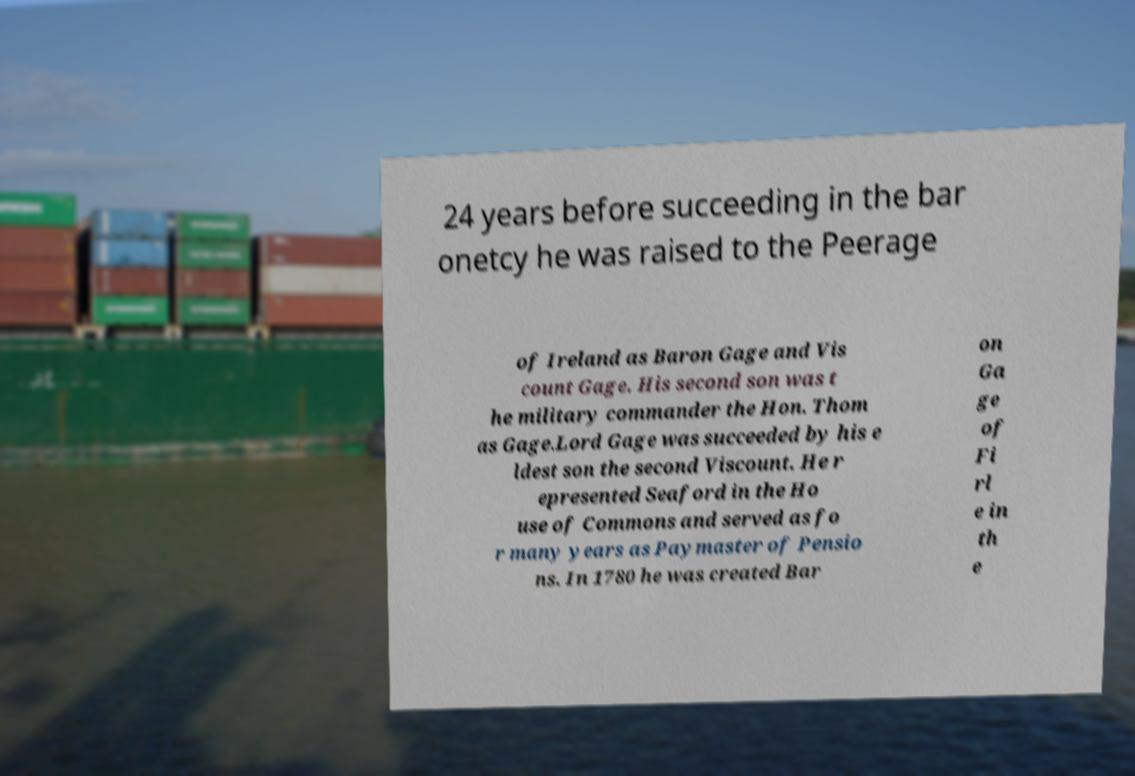What messages or text are displayed in this image? I need them in a readable, typed format. 24 years before succeeding in the bar onetcy he was raised to the Peerage of Ireland as Baron Gage and Vis count Gage. His second son was t he military commander the Hon. Thom as Gage.Lord Gage was succeeded by his e ldest son the second Viscount. He r epresented Seaford in the Ho use of Commons and served as fo r many years as Paymaster of Pensio ns. In 1780 he was created Bar on Ga ge of Fi rl e in th e 